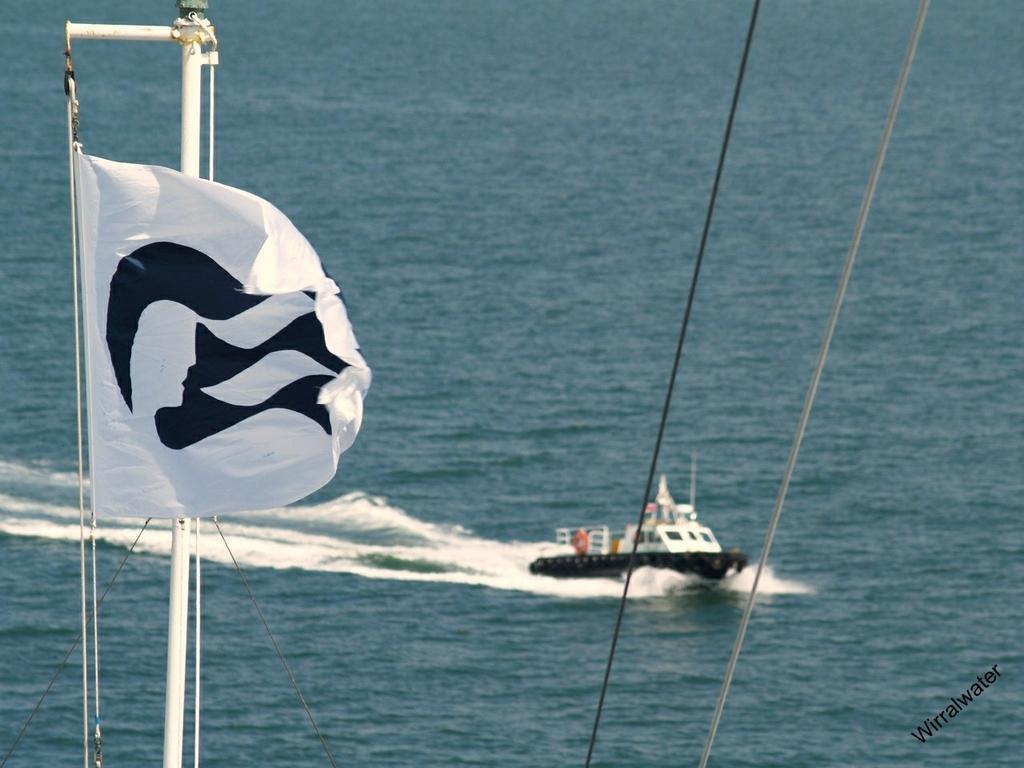How would you summarize this image in a sentence or two? In this picture we can see water and a ship riding in the water and we have poles and a flag to poles and some wires. 